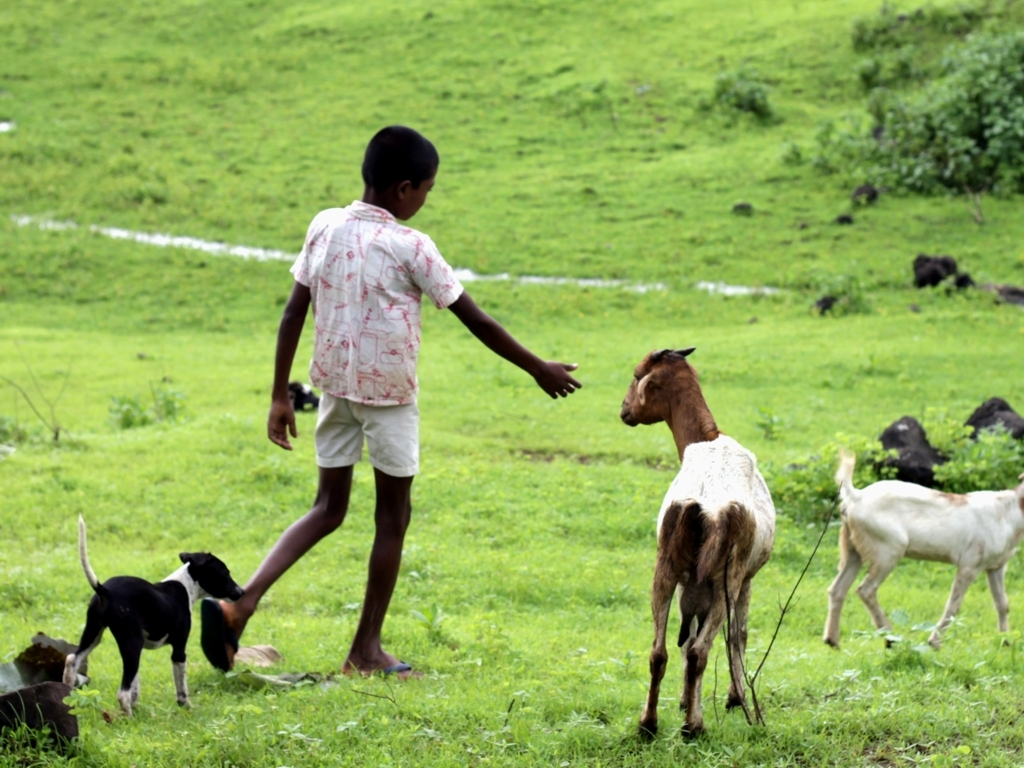Do the colors in the image look vibrant and vivid?
A. Yes
B. No
Answer with the option's letter from the given choices directly.
 A. 